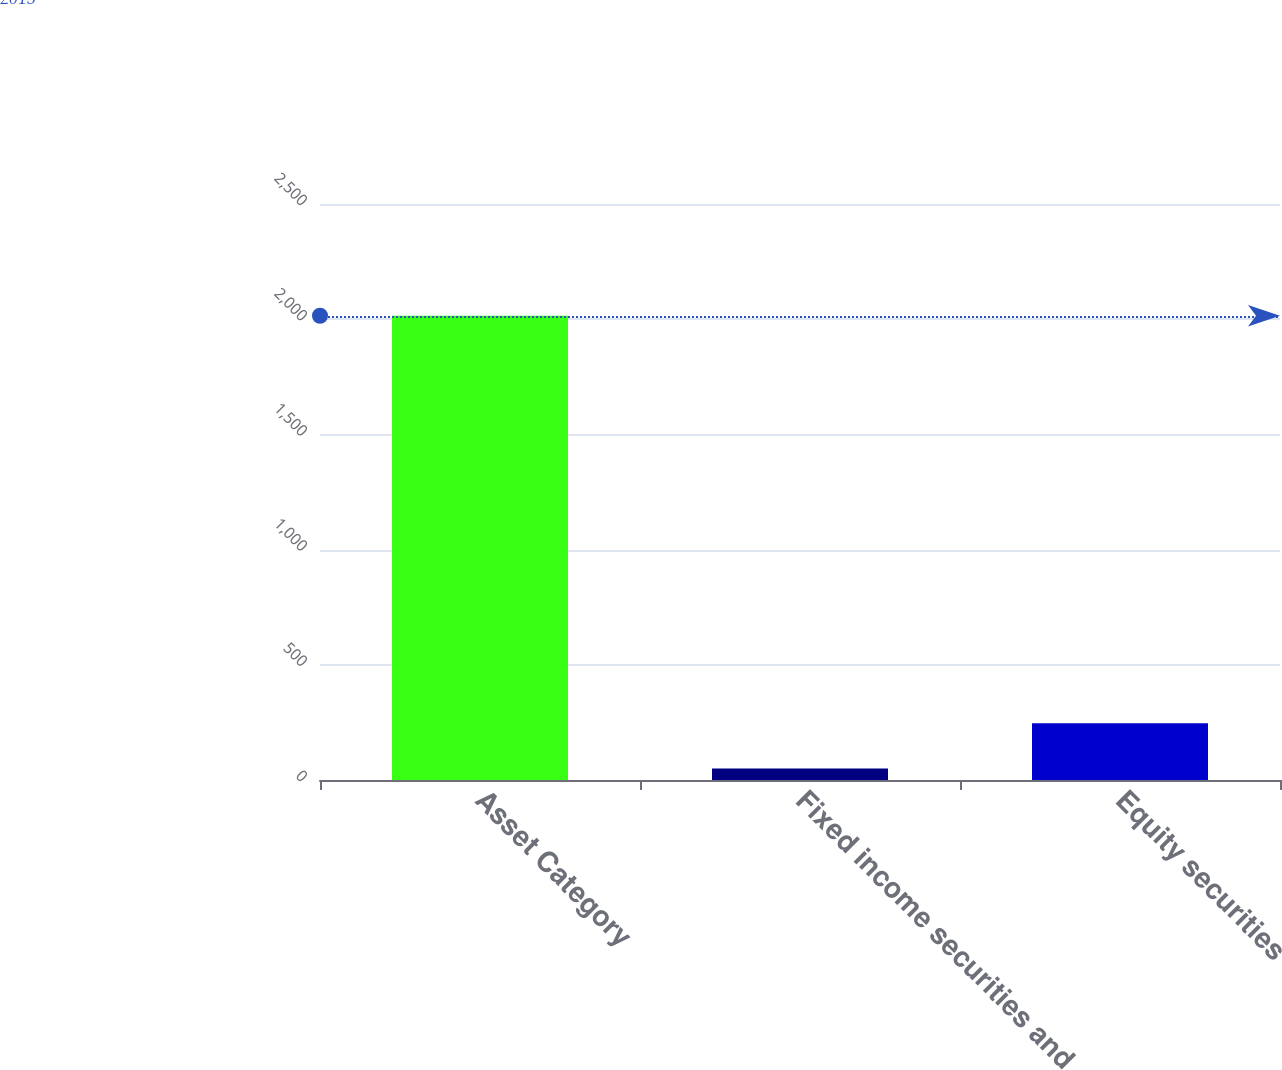Convert chart to OTSL. <chart><loc_0><loc_0><loc_500><loc_500><bar_chart><fcel>Asset Category<fcel>Fixed income securities and<fcel>Equity securities<nl><fcel>2015<fcel>50<fcel>246.5<nl></chart> 